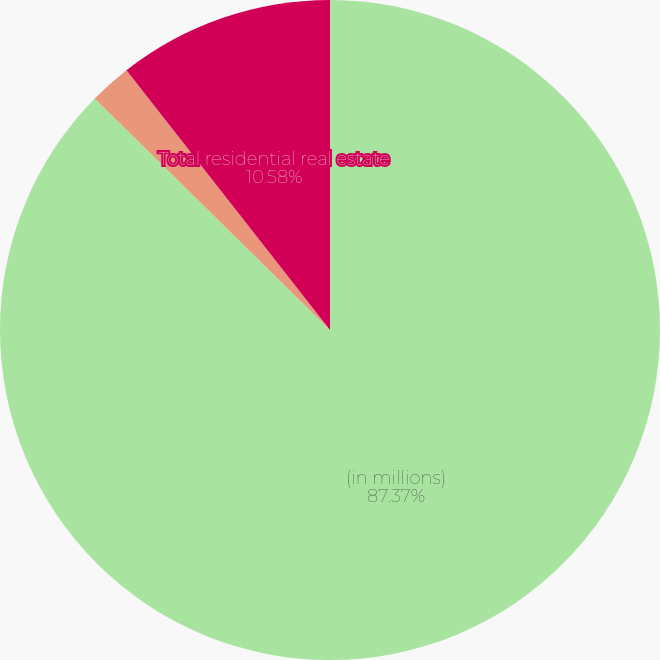<chart> <loc_0><loc_0><loc_500><loc_500><pie_chart><fcel>(in millions)<fcel>Subprime<fcel>Total residential real estate<nl><fcel>87.38%<fcel>2.05%<fcel>10.58%<nl></chart> 